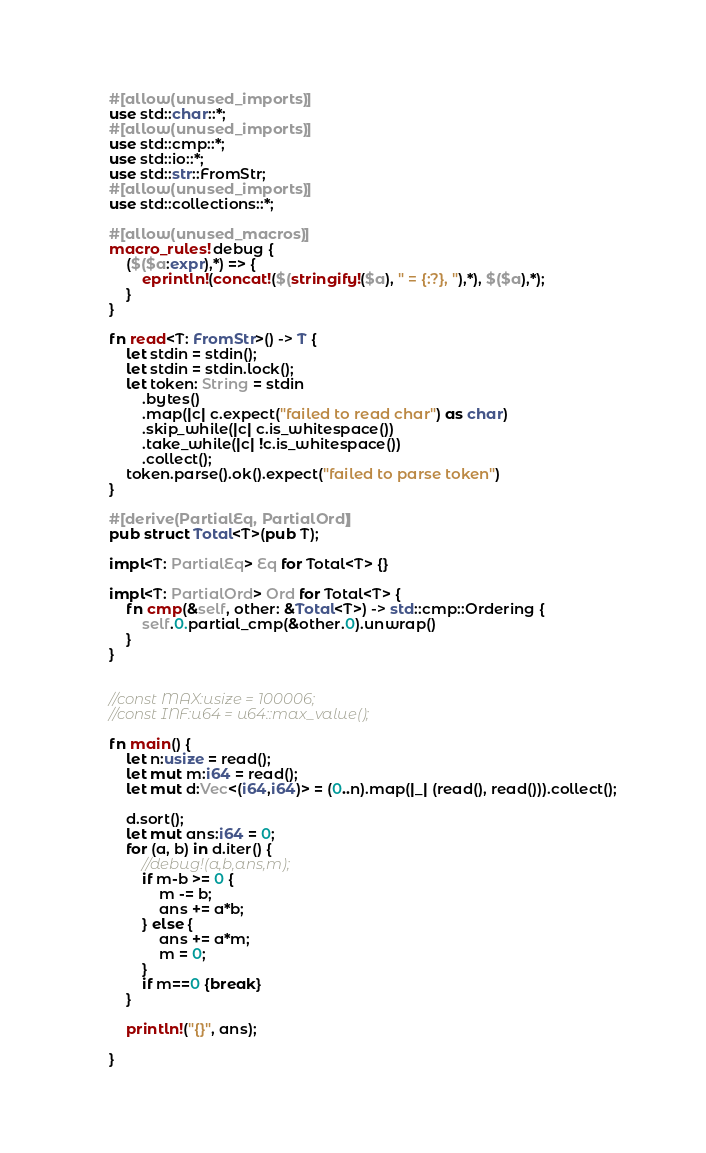<code> <loc_0><loc_0><loc_500><loc_500><_Rust_>#[allow(unused_imports)]
use std::char::*;
#[allow(unused_imports)]
use std::cmp::*;
use std::io::*;
use std::str::FromStr;
#[allow(unused_imports)]
use std::collections::*;

#[allow(unused_macros)]
macro_rules! debug {
    ($($a:expr),*) => {
        eprintln!(concat!($(stringify!($a), " = {:?}, "),*), $($a),*);
    }
}

fn read<T: FromStr>() -> T {
    let stdin = stdin();
    let stdin = stdin.lock();
    let token: String = stdin
        .bytes()
        .map(|c| c.expect("failed to read char") as char)
        .skip_while(|c| c.is_whitespace())
        .take_while(|c| !c.is_whitespace())
        .collect();
    token.parse().ok().expect("failed to parse token")
}

#[derive(PartialEq, PartialOrd)]
pub struct Total<T>(pub T);

impl<T: PartialEq> Eq for Total<T> {}

impl<T: PartialOrd> Ord for Total<T> {
    fn cmp(&self, other: &Total<T>) -> std::cmp::Ordering {
        self.0.partial_cmp(&other.0).unwrap()
    }
}


//const MAX:usize = 100006;
//const INF:u64 = u64::max_value();

fn main() {
    let n:usize = read();
    let mut m:i64 = read();
    let mut d:Vec<(i64,i64)> = (0..n).map(|_| (read(), read())).collect();

    d.sort();
    let mut ans:i64 = 0;
    for (a, b) in d.iter() {
        //debug!(a,b,ans,m);
        if m-b >= 0 {
            m -= b;
            ans += a*b;
        } else {
            ans += a*m;
            m = 0;
        }
        if m==0 {break}
    }

    println!("{}", ans);

}
</code> 